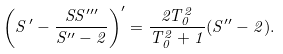Convert formula to latex. <formula><loc_0><loc_0><loc_500><loc_500>\left ( S ^ { \, \prime } - \frac { S S ^ { \prime \prime \prime } } { S ^ { \prime \prime } - 2 } \right ) ^ { \prime } = \frac { 2 T _ { 0 } ^ { 2 } } { T _ { 0 } ^ { 2 } + 1 } ( S ^ { \prime \prime } - 2 ) .</formula> 